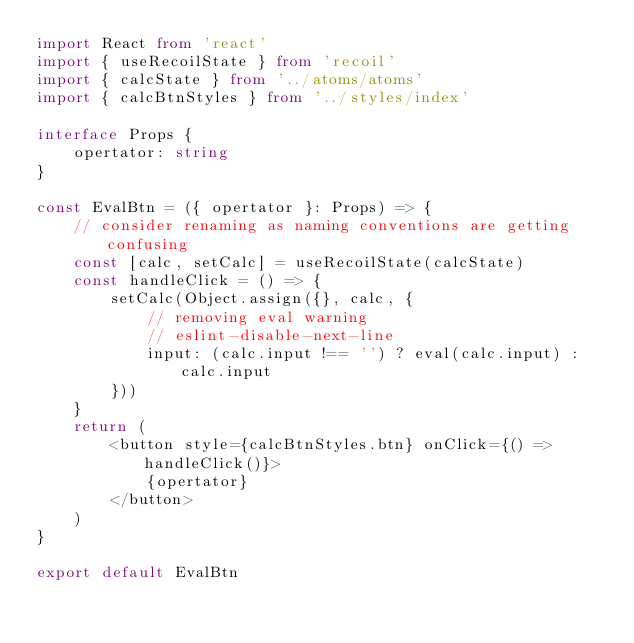<code> <loc_0><loc_0><loc_500><loc_500><_TypeScript_>import React from 'react'
import { useRecoilState } from 'recoil'
import { calcState } from '../atoms/atoms'
import { calcBtnStyles } from '../styles/index'

interface Props {
    opertator: string
}

const EvalBtn = ({ opertator }: Props) => {
    // consider renaming as naming conventions are getting confusing
    const [calc, setCalc] = useRecoilState(calcState)
    const handleClick = () => {
        setCalc(Object.assign({}, calc, {
            // removing eval warning
            // eslint-disable-next-line 
            input: (calc.input !== '') ? eval(calc.input) : calc.input
        }))
    }
    return (
        <button style={calcBtnStyles.btn} onClick={() => handleClick()}>
            {opertator}
        </button>
    )
}

export default EvalBtn
</code> 